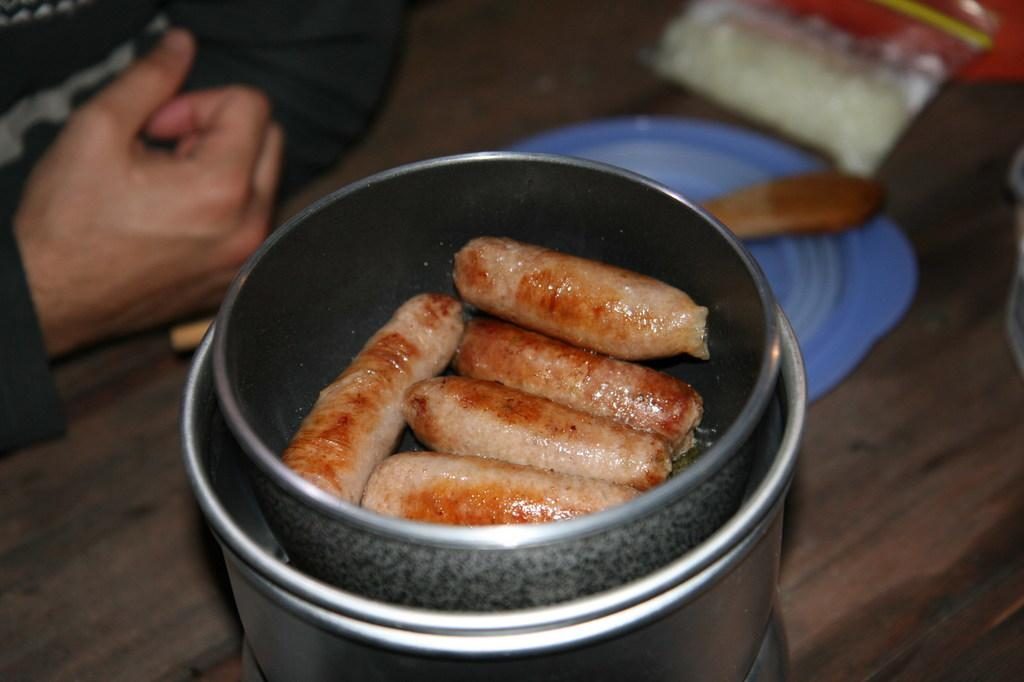What is in the bowl that is visible in the image? There is a bowl with food in the image. How is the bowl stored or contained in the image? The bowl is kept in a small container. What other dish is present in the image besides the bowl? There is a plate in the image. What type of material is the wooden object made of? The wooden object is made of wood. What is the packaging item in the image? There is a packet in the image. Whose hands are visible in the image? The hands of a person are visible in the image. On what surface is the bowl and plate placed? There is a wooden table in the image. What type of brass instrument is being played in the image? There is no brass instrument or any indication of music being played in the image. 